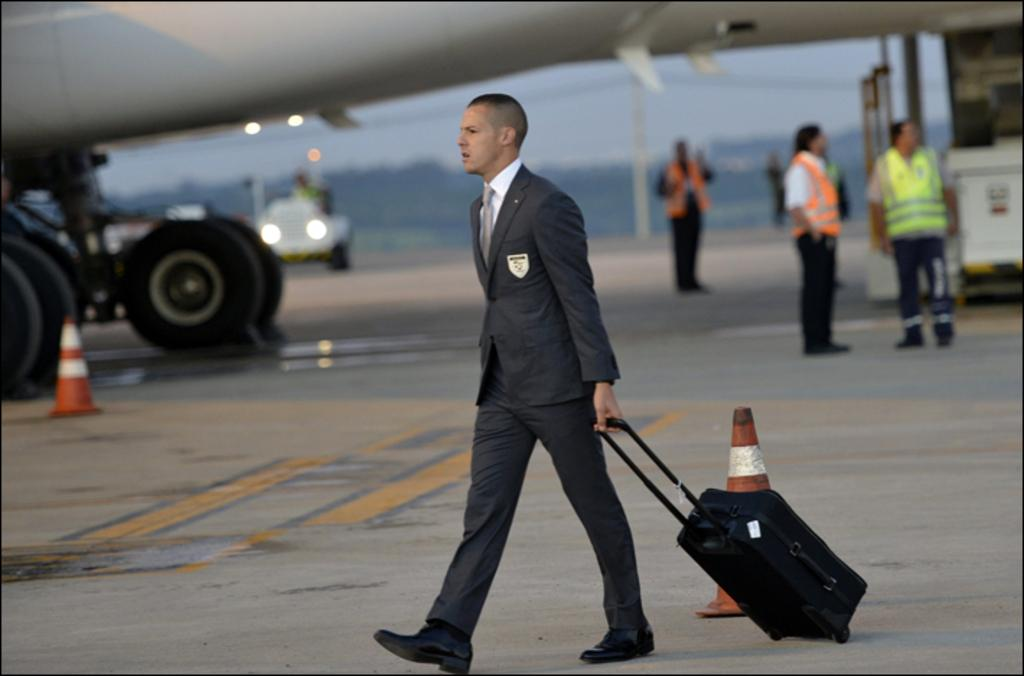Who is present in the image? There is a man in the image. What is the man doing in the image? The man is carrying luggage. What can be seen in the background of the image? There is an airplane in the image. Are there any other people in the image? Yes, there are other people around the airplane. What song is the man singing in the image? There is no indication in the image that the man is singing a song, so it cannot be determined from the picture. 